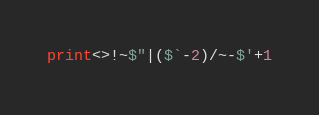Convert code to text. <code><loc_0><loc_0><loc_500><loc_500><_Perl_>print<>!~$"|($`-2)/~-$'+1</code> 